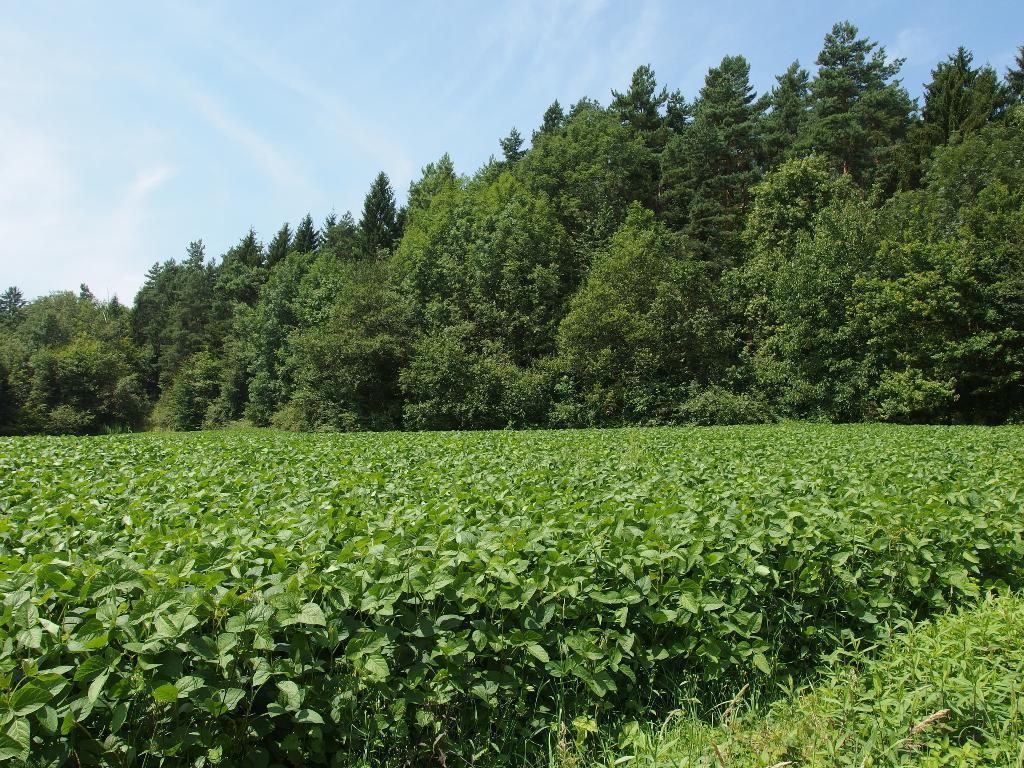Can you describe this image briefly? In this picture we can see green plants. In the background of the image we can see trees and sky. 